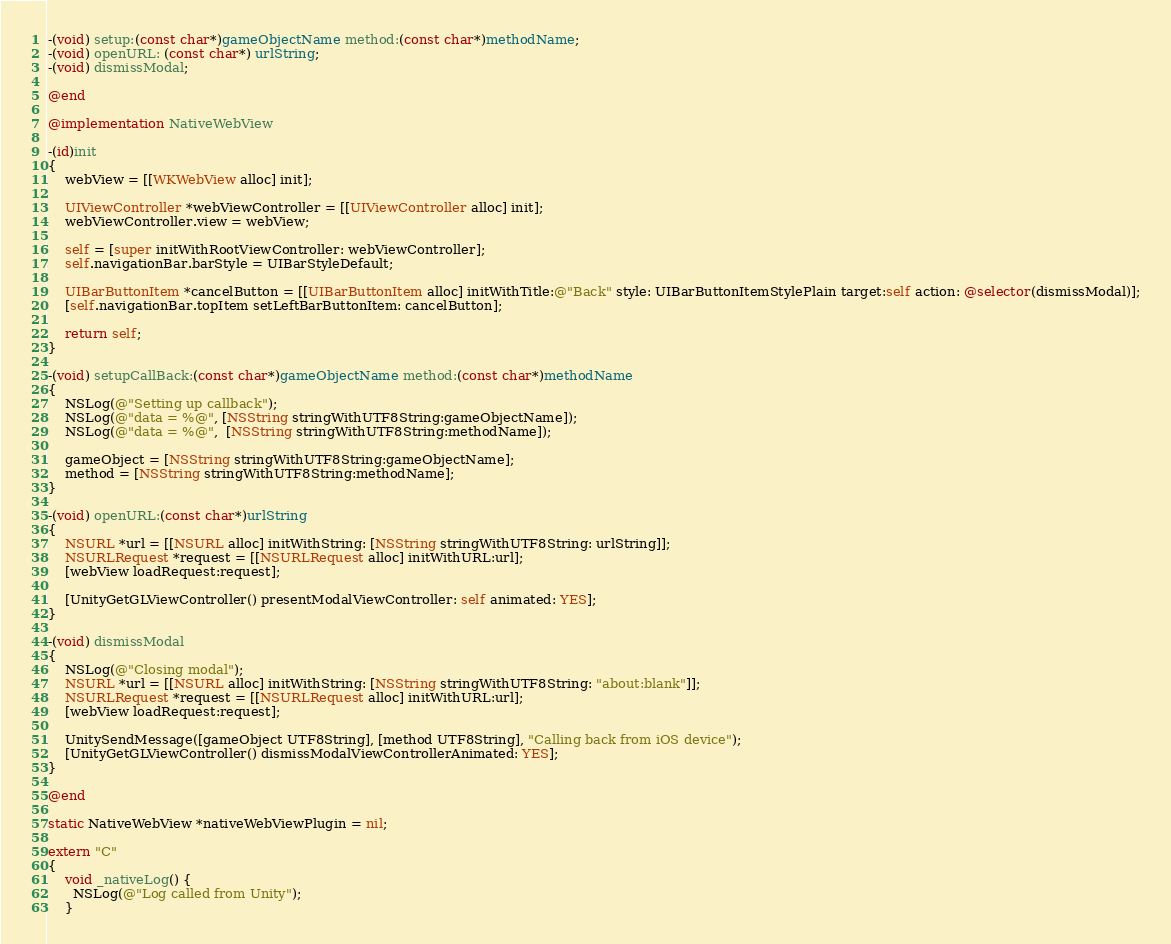<code> <loc_0><loc_0><loc_500><loc_500><_ObjectiveC_>-(void) setup:(const char*)gameObjectName method:(const char*)methodName;
-(void) openURL: (const char*) urlString;
-(void) dismissModal;

@end

@implementation NativeWebView

-(id)init
{
    webView = [[WKWebView alloc] init];

    UIViewController *webViewController = [[UIViewController alloc] init];
    webViewController.view = webView;

    self = [super initWithRootViewController: webViewController];
    self.navigationBar.barStyle = UIBarStyleDefault;
    
    UIBarButtonItem *cancelButton = [[UIBarButtonItem alloc] initWithTitle:@"Back" style: UIBarButtonItemStylePlain target:self action: @selector(dismissModal)];
    [self.navigationBar.topItem setLeftBarButtonItem: cancelButton];
    
    return self;
}

-(void) setupCallBack:(const char*)gameObjectName method:(const char*)methodName
{
	NSLog(@"Setting up callback");
    NSLog(@"data = %@", [NSString stringWithUTF8String:gameObjectName]);
    NSLog(@"data = %@",  [NSString stringWithUTF8String:methodName]);

    gameObject = [NSString stringWithUTF8String:gameObjectName];
	method = [NSString stringWithUTF8String:methodName];
}

-(void) openURL:(const char*)urlString
{
    NSURL *url = [[NSURL alloc] initWithString: [NSString stringWithUTF8String: urlString]];
    NSURLRequest *request = [[NSURLRequest alloc] initWithURL:url];
    [webView loadRequest:request];

    [UnityGetGLViewController() presentModalViewController: self animated: YES];
}

-(void) dismissModal
{
	NSLog(@"Closing modal");
    NSURL *url = [[NSURL alloc] initWithString: [NSString stringWithUTF8String: "about:blank"]];
    NSURLRequest *request = [[NSURLRequest alloc] initWithURL:url];
    [webView loadRequest:request];

	UnitySendMessage([gameObject UTF8String], [method UTF8String], "Calling back from iOS device");
 	[UnityGetGLViewController() dismissModalViewControllerAnimated: YES];
}

@end

static NativeWebView *nativeWebViewPlugin = nil;

extern "C"
{
	void _nativeLog() {
      NSLog(@"Log called from Unity");
	}
</code> 